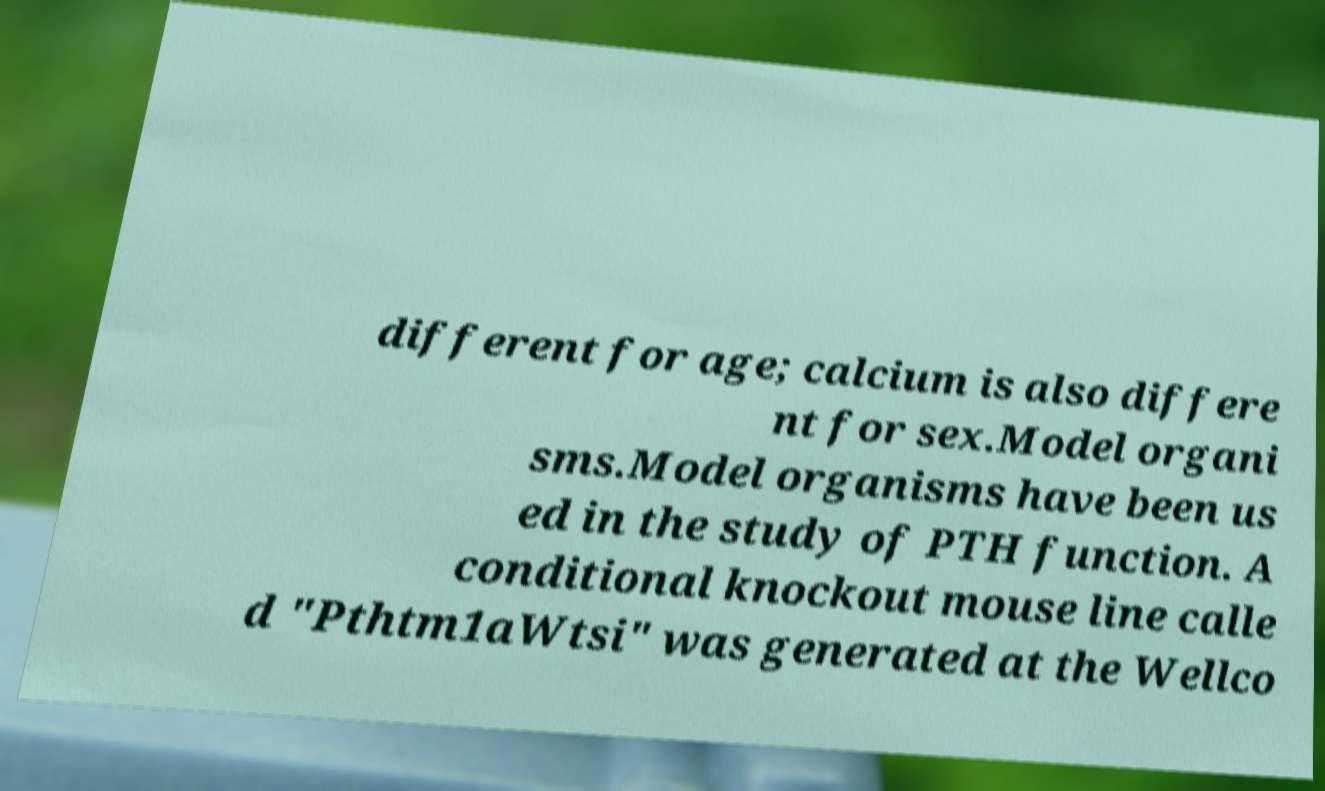Can you read and provide the text displayed in the image?This photo seems to have some interesting text. Can you extract and type it out for me? different for age; calcium is also differe nt for sex.Model organi sms.Model organisms have been us ed in the study of PTH function. A conditional knockout mouse line calle d "Pthtm1aWtsi" was generated at the Wellco 